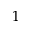<formula> <loc_0><loc_0><loc_500><loc_500>^ { 1 }</formula> 